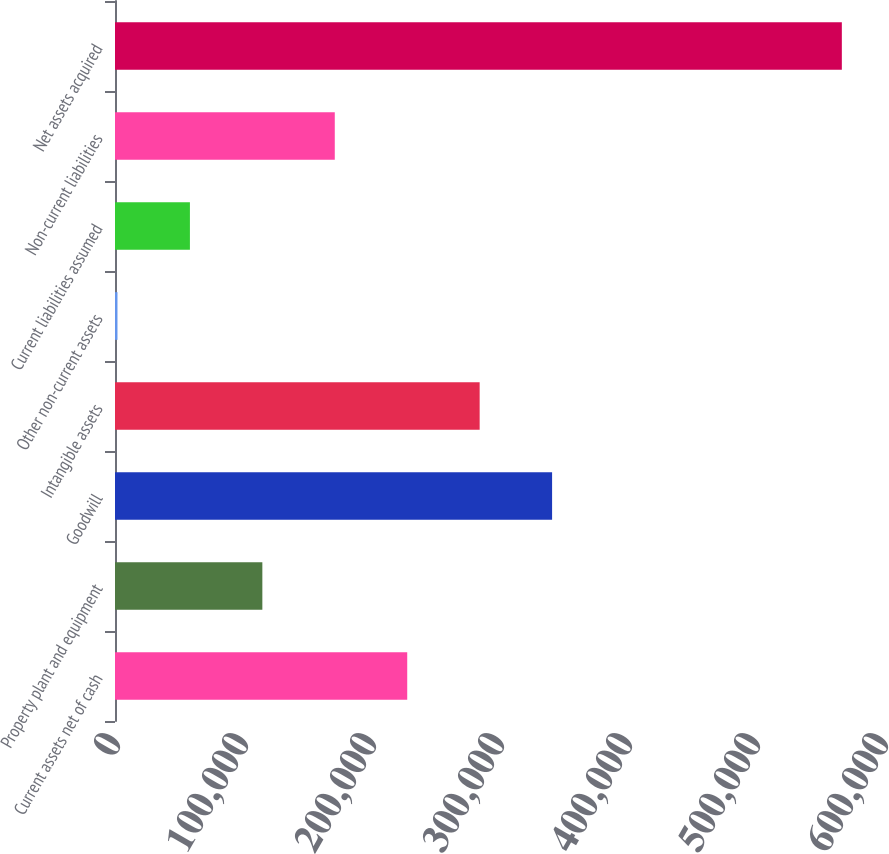Convert chart. <chart><loc_0><loc_0><loc_500><loc_500><bar_chart><fcel>Current assets net of cash<fcel>Property plant and equipment<fcel>Goodwill<fcel>Intangible assets<fcel>Other non-current assets<fcel>Current liabilities assumed<fcel>Non-current liabilities<fcel>Net assets acquired<nl><fcel>228298<fcel>115116<fcel>341479<fcel>284888<fcel>1934<fcel>58524.9<fcel>171707<fcel>567843<nl></chart> 